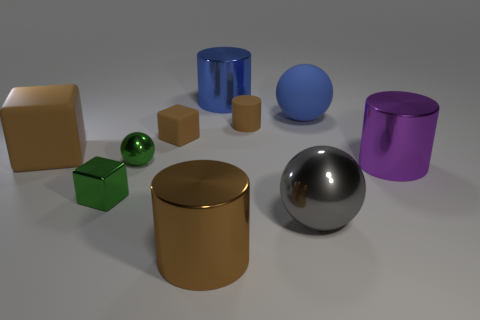Subtract all large shiny cylinders. How many cylinders are left? 1 Subtract all yellow blocks. How many brown cylinders are left? 2 Subtract all purple cylinders. How many cylinders are left? 3 Subtract 2 cylinders. How many cylinders are left? 2 Subtract all yellow blocks. Subtract all cyan spheres. How many blocks are left? 3 Subtract all small spheres. Subtract all large cubes. How many objects are left? 8 Add 5 rubber balls. How many rubber balls are left? 6 Add 5 cylinders. How many cylinders exist? 9 Subtract 0 purple balls. How many objects are left? 10 Subtract all cylinders. How many objects are left? 6 